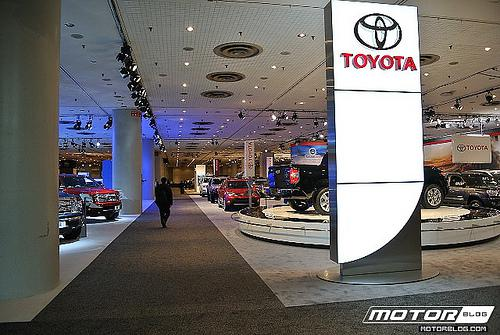Question: where is this scene?
Choices:
A. In an airplane.
B. At the bar.
C. At a car showroom.
D. Behind the fence.
Answer with the letter. Answer: C Question: why are there cars?
Choices:
A. There is a car show.
B. It is a parking lot.
C. It is a freeway.
D. Display.
Answer with the letter. Answer: D Question: what else is in the photo?
Choices:
A. Trucks.
B. Trains.
C. Cars.
D. Boats.
Answer with the letter. Answer: C Question: how is the man?
Choices:
A. In motion.
B. Sitting.
C. Standing.
D. Running.
Answer with the letter. Answer: A 